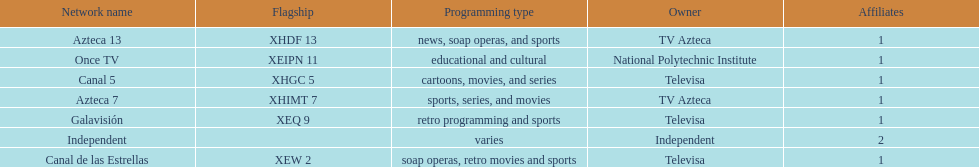Azteca 7 and azteca 13 are both owned by whom? TV Azteca. 